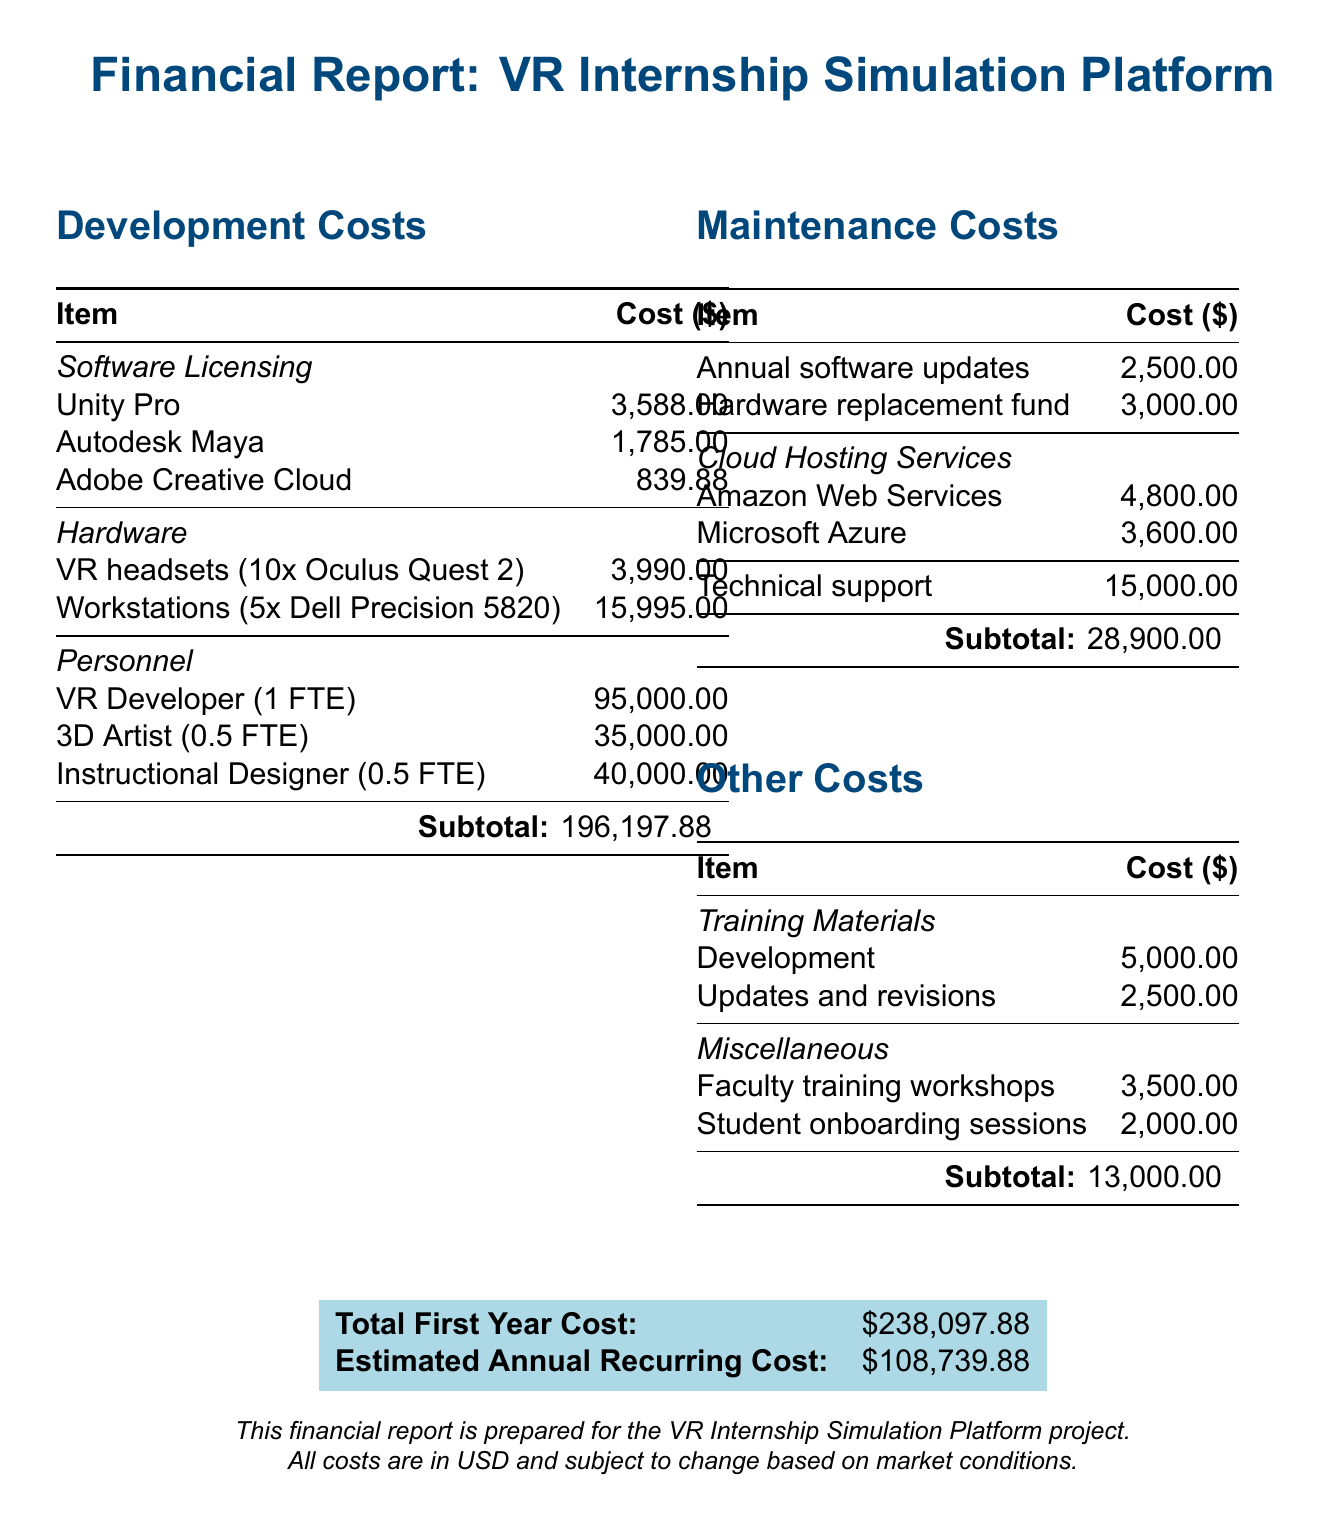What is the total first year cost? The total first year cost is presented at the end of the document, summing all expenses related to the project in the first year.
Answer: $238,097.88 How many VR headsets were purchased? The document specifies that 10 Oculus Quest 2 VR headsets were purchased under hardware costs.
Answer: 10 What is the cost of the VR Developer? The document lists the cost for the VR Developer at 1 Full-Time Equivalent (FTE) among personnel expenses.
Answer: $95,000 What are the annual software updates cost? The maintenance costs section explicitly states the cost for annual software updates as listed.
Answer: $2,500 What is the total maintenance cost? The total maintenance cost is the sum of all maintenance-related expenses mentioned in the document.
Answer: $28,900.00 What is the cost for training materials development? The document indicates a specific expense for the development of training materials.
Answer: $5,000.00 What is the total estimated annual recurring cost? The estimated annual recurring cost is provided at the end of the financial report, summarizing future costs.
Answer: $108,739.88 What type of technical support is included? The document simply mentions "Technical support" as part of the maintenance costs without further detail.
Answer: Technical support What is the total cost for faculty training workshops? The miscellaneous section of the document lists the cost specifically for faculty training workshops.
Answer: $3,500.00 